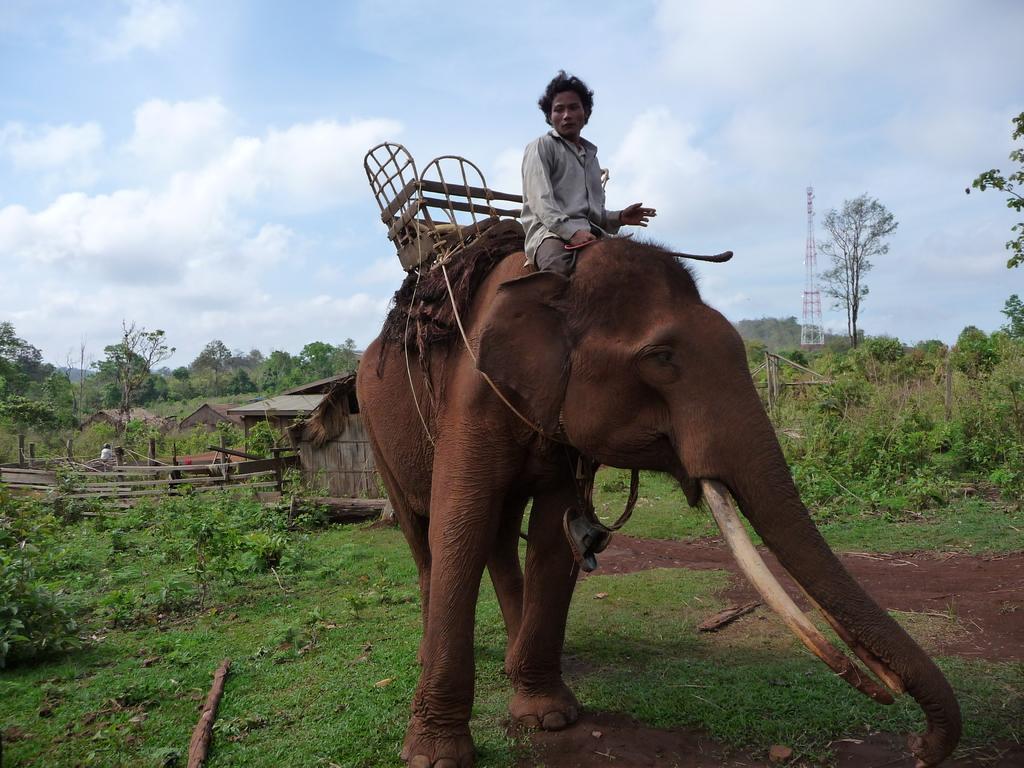Please provide a concise description of this image. In this image I can see a person sitting on the elephant. At the back of him there are trees and the sky. 